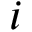Convert formula to latex. <formula><loc_0><loc_0><loc_500><loc_500>i</formula> 